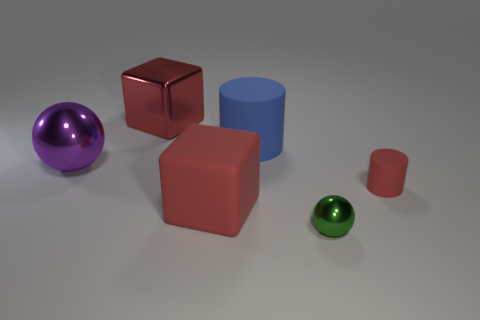What do the colors of the objects in the picture suggest about the lighting in the scene? The various colors, which include a shiny red, matte red, blue, and purple, show that the objects are likely under a neutral white light source, allowing their true colors to stand out without any color cast. 